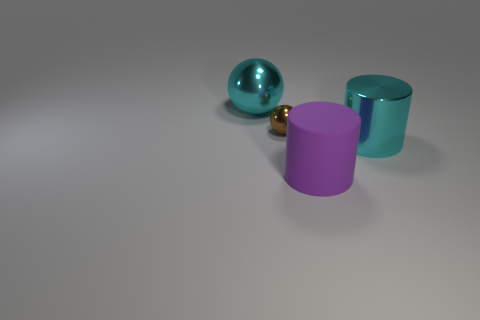Add 1 small brown metallic balls. How many objects exist? 5 Subtract 2 cylinders. How many cylinders are left? 0 Subtract all big cyan cylinders. Subtract all large purple objects. How many objects are left? 2 Add 2 large matte objects. How many large matte objects are left? 3 Add 1 big cyan metal objects. How many big cyan metal objects exist? 3 Subtract 0 gray cylinders. How many objects are left? 4 Subtract all red cylinders. Subtract all red blocks. How many cylinders are left? 2 